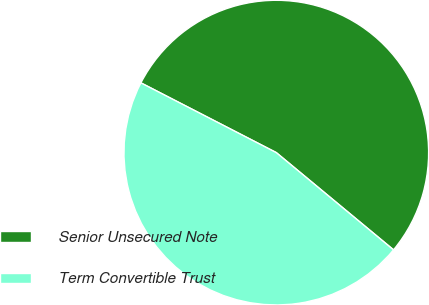Convert chart to OTSL. <chart><loc_0><loc_0><loc_500><loc_500><pie_chart><fcel>Senior Unsecured Note<fcel>Term Convertible Trust<nl><fcel>53.45%<fcel>46.55%<nl></chart> 